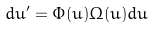<formula> <loc_0><loc_0><loc_500><loc_500>d u ^ { \prime } = \Phi ( u ) \Omega ( u ) d u</formula> 